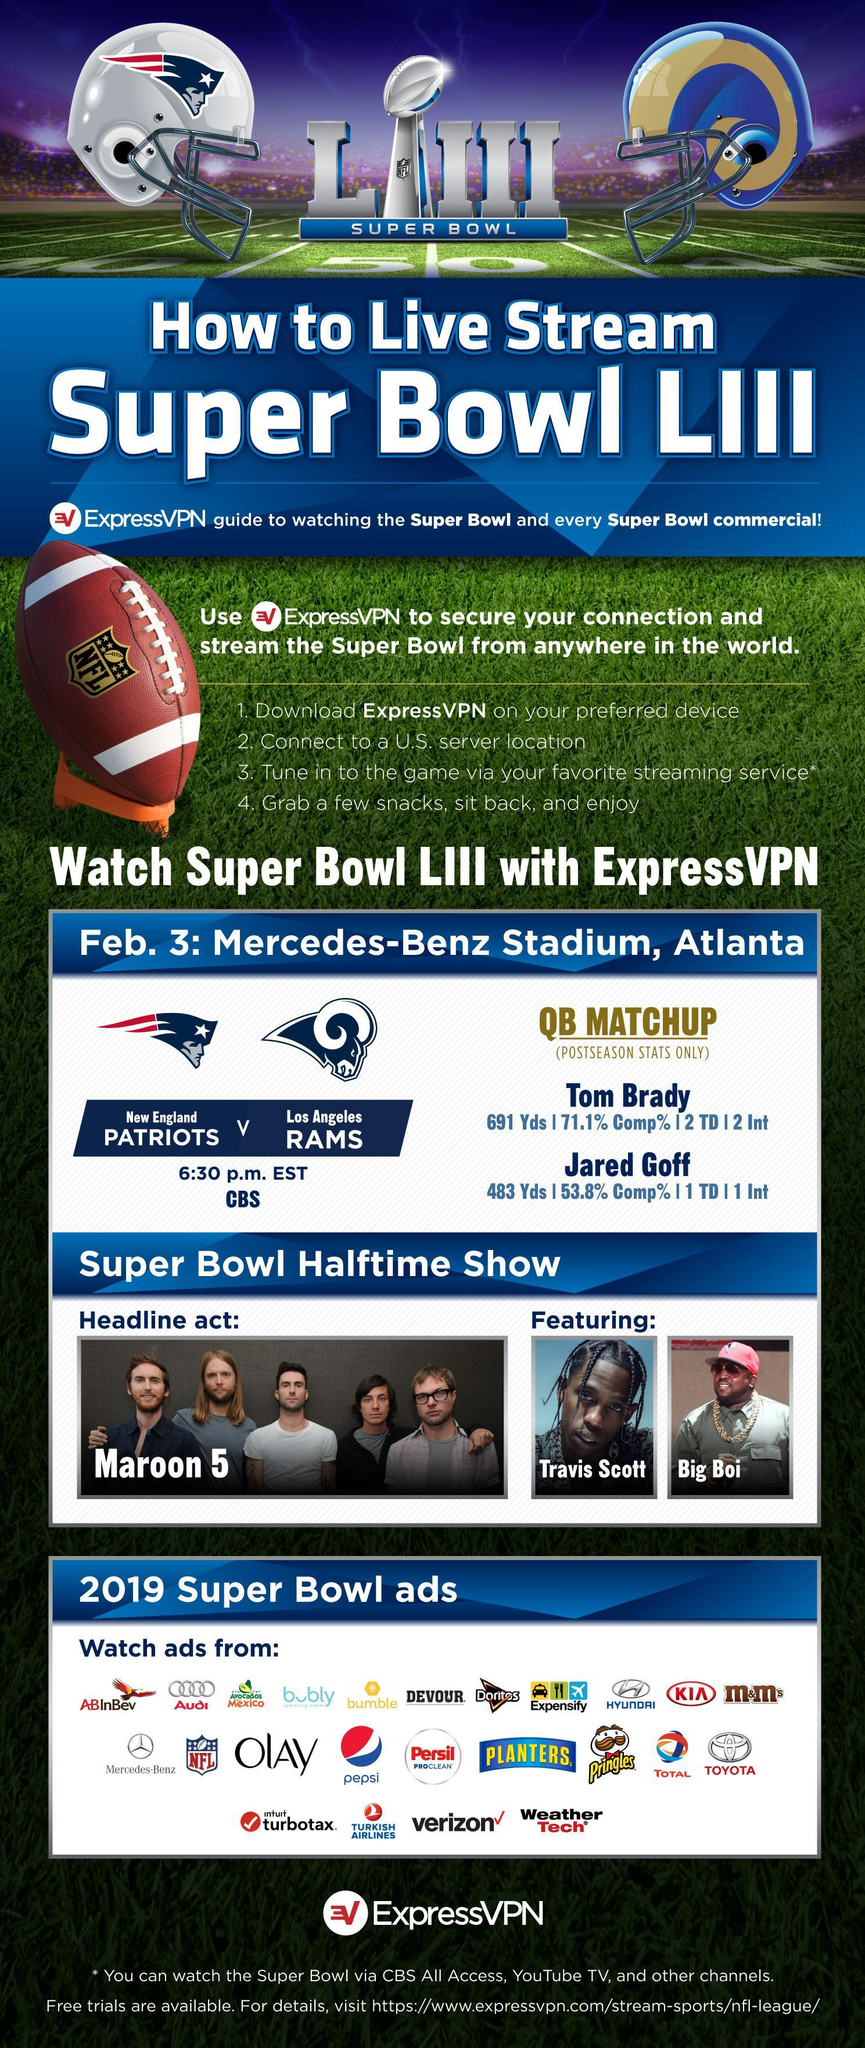How many car companies are featured in the ads?
Answer the question with a short phrase. 5 